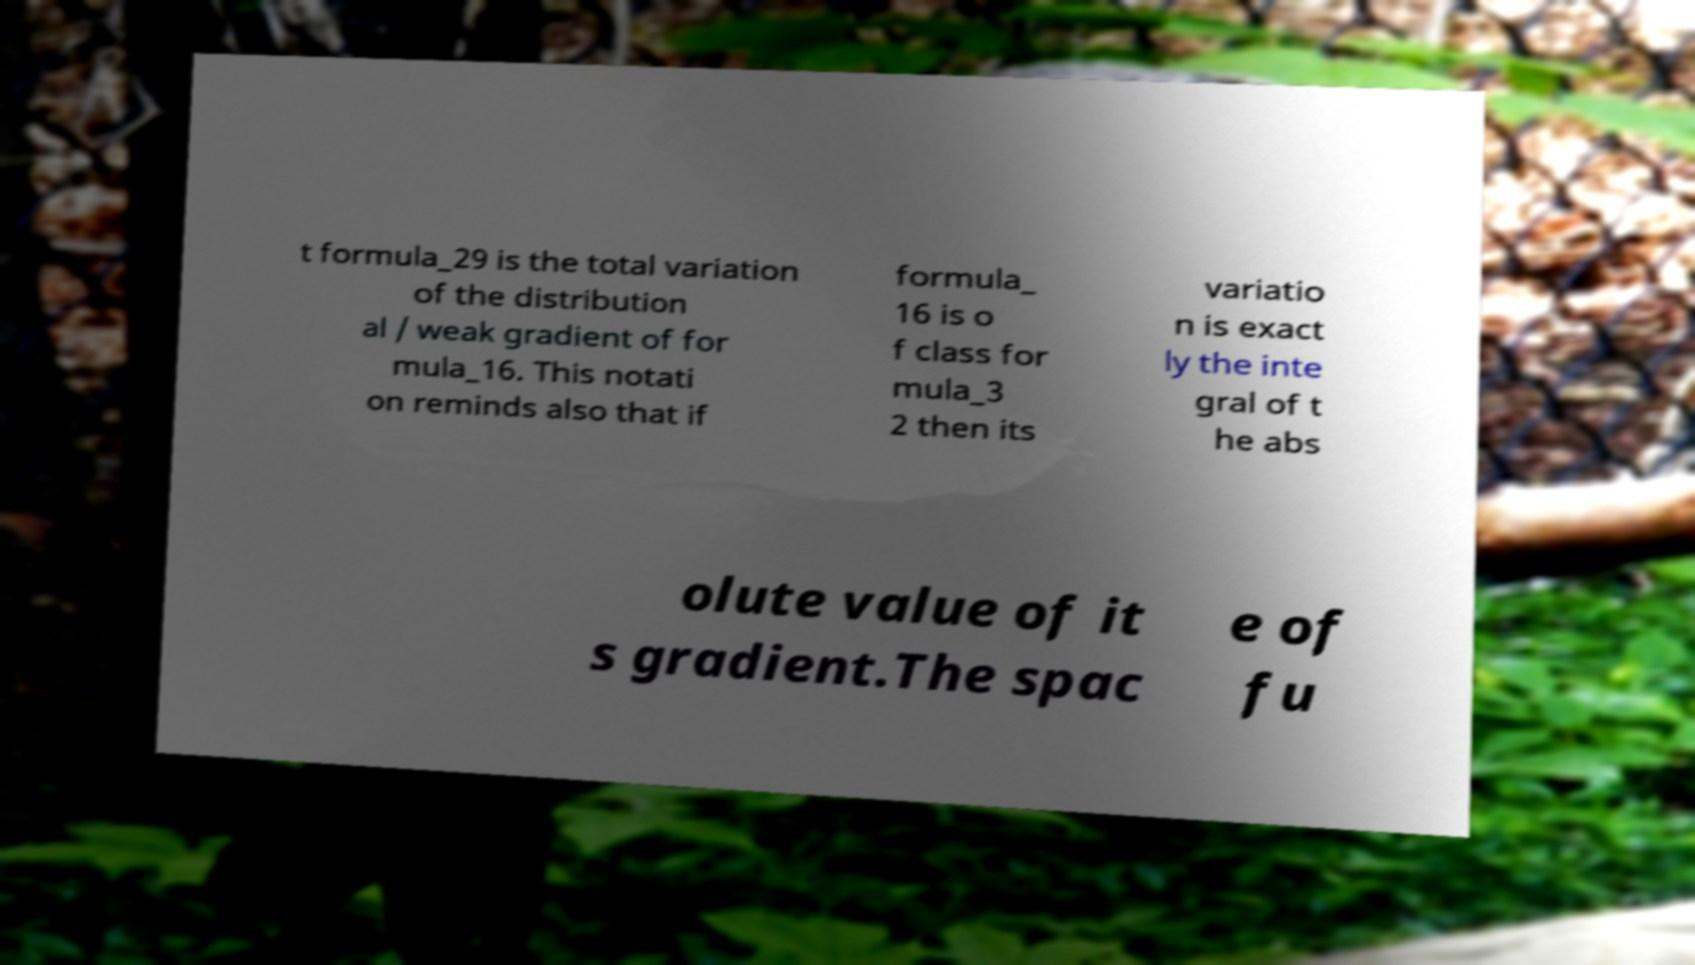Can you read and provide the text displayed in the image?This photo seems to have some interesting text. Can you extract and type it out for me? t formula_29 is the total variation of the distribution al / weak gradient of for mula_16. This notati on reminds also that if formula_ 16 is o f class for mula_3 2 then its variatio n is exact ly the inte gral of t he abs olute value of it s gradient.The spac e of fu 